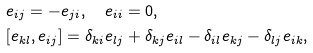Convert formula to latex. <formula><loc_0><loc_0><loc_500><loc_500>& e _ { i j } = - e _ { j i } , \quad e _ { i i } = 0 , \\ & [ e _ { k l } , e _ { i j } ] = \delta _ { k i } e _ { l j } + \delta _ { k j } e _ { i l } - \delta _ { i l } e _ { k j } - \delta _ { l j } e _ { i k } ,</formula> 